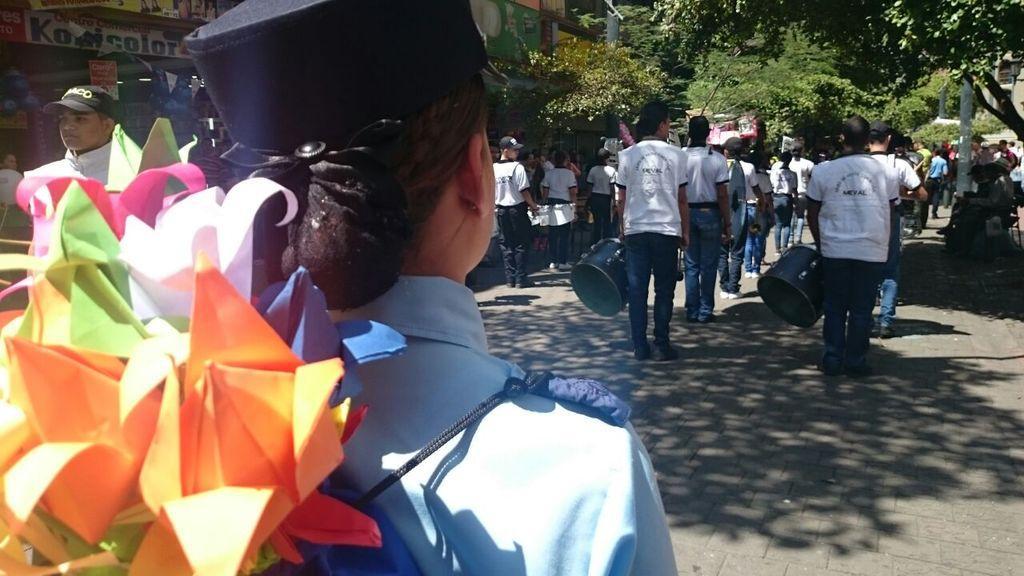Describe this image in one or two sentences. In this image we can see people, road, boards, paper crafts, poles, trees, and other objects. 